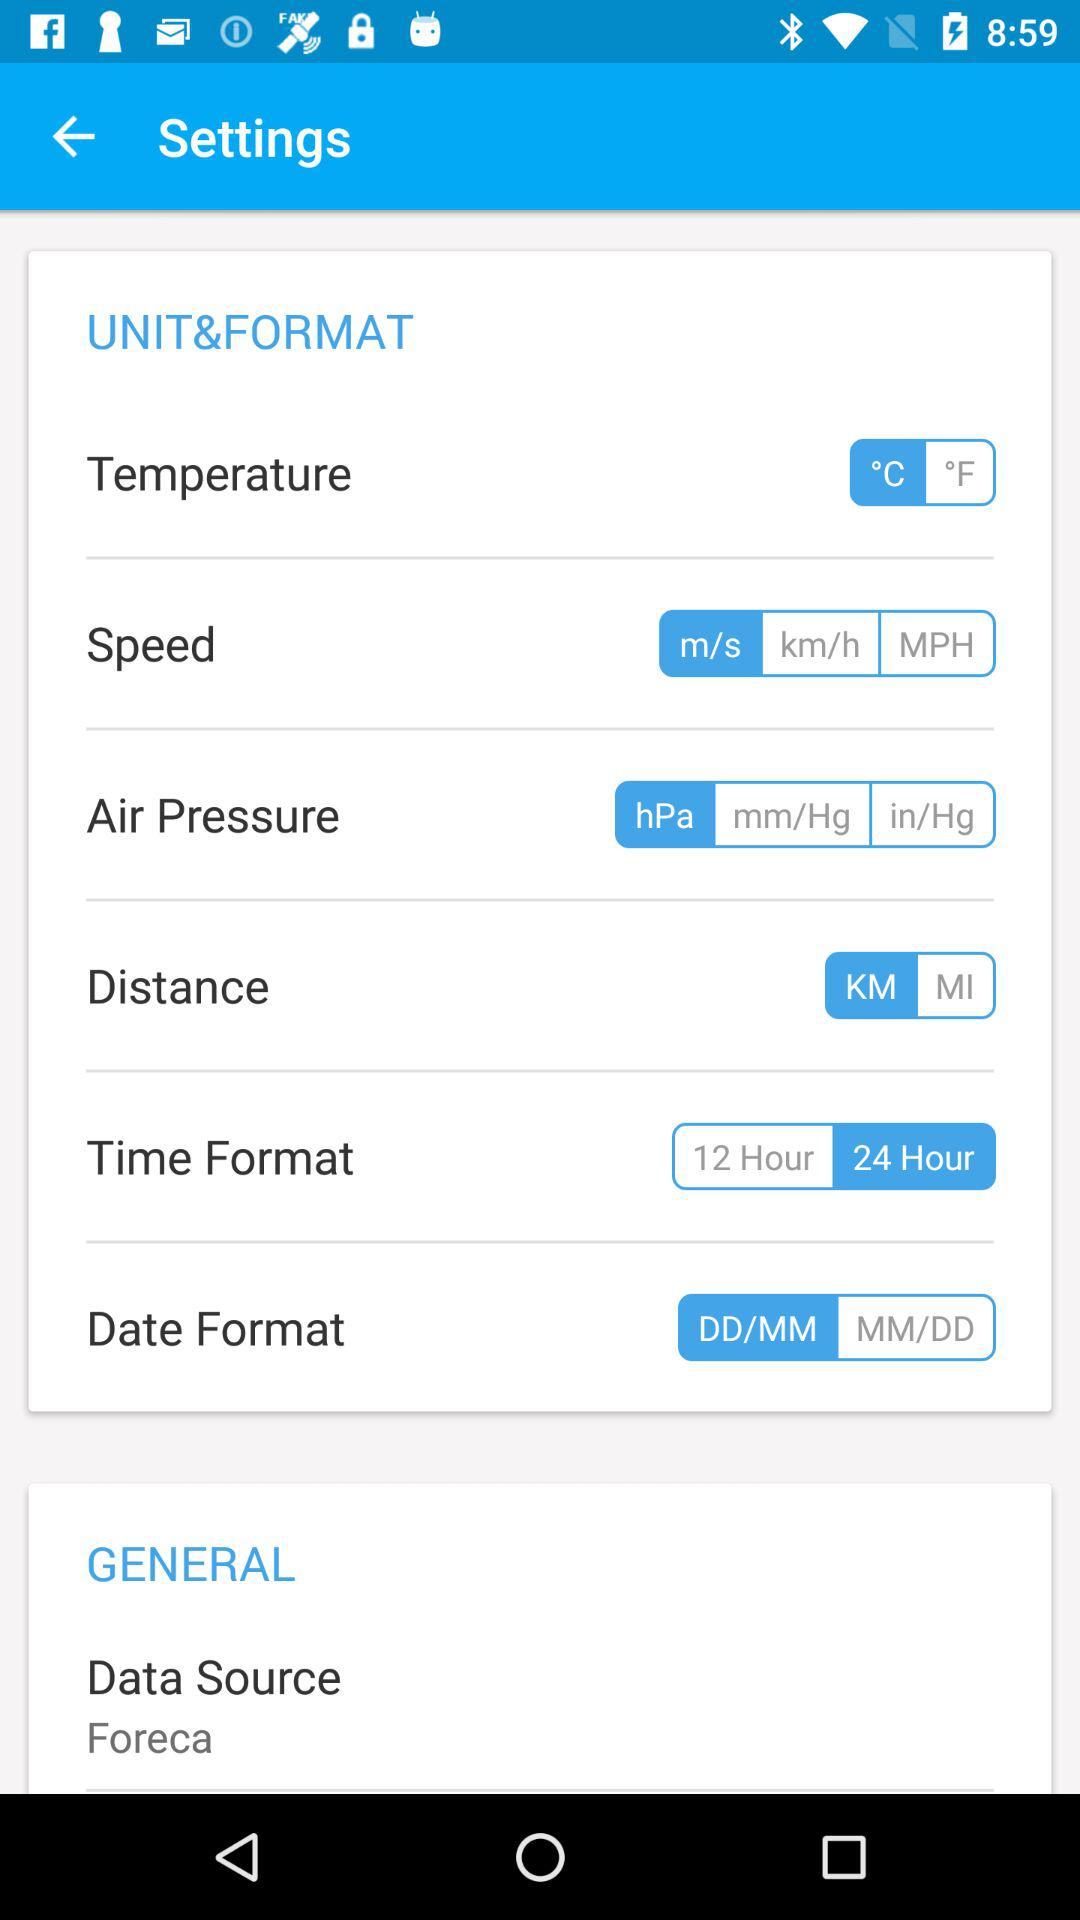How many units are available for temperature?
Answer the question using a single word or phrase. 2 